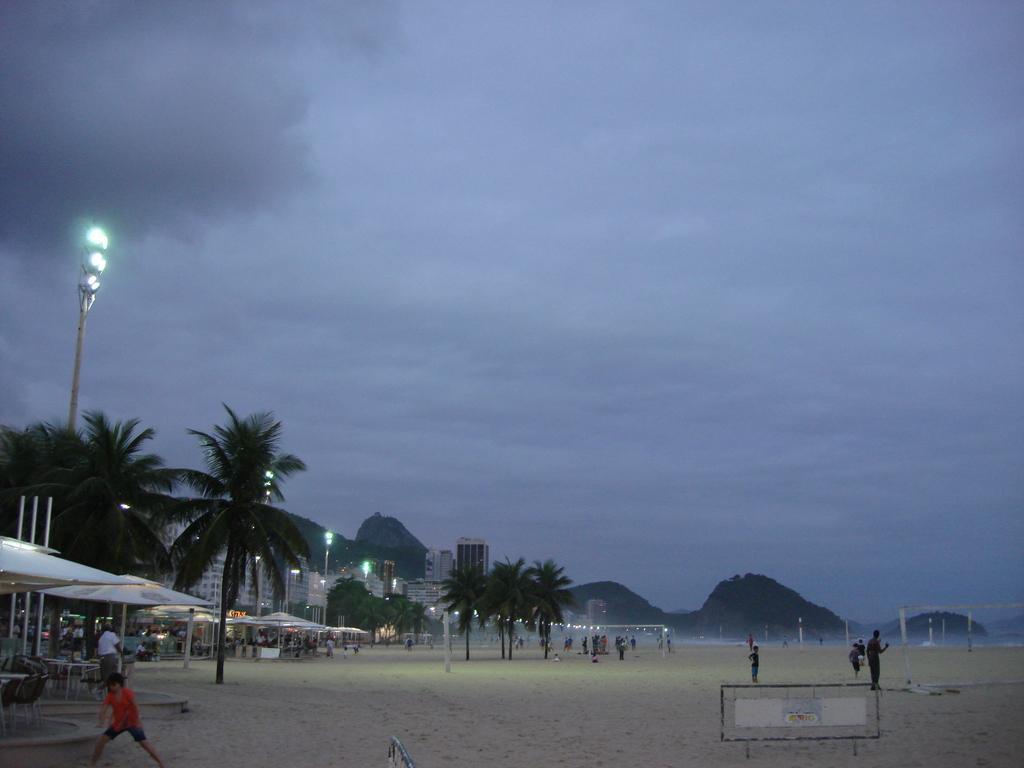Can you describe this image briefly? In this image I can see many people on the sand. To the left I can see the tents, many trees, light poles and the buildings. In the background I can see the mountains and the sky. 